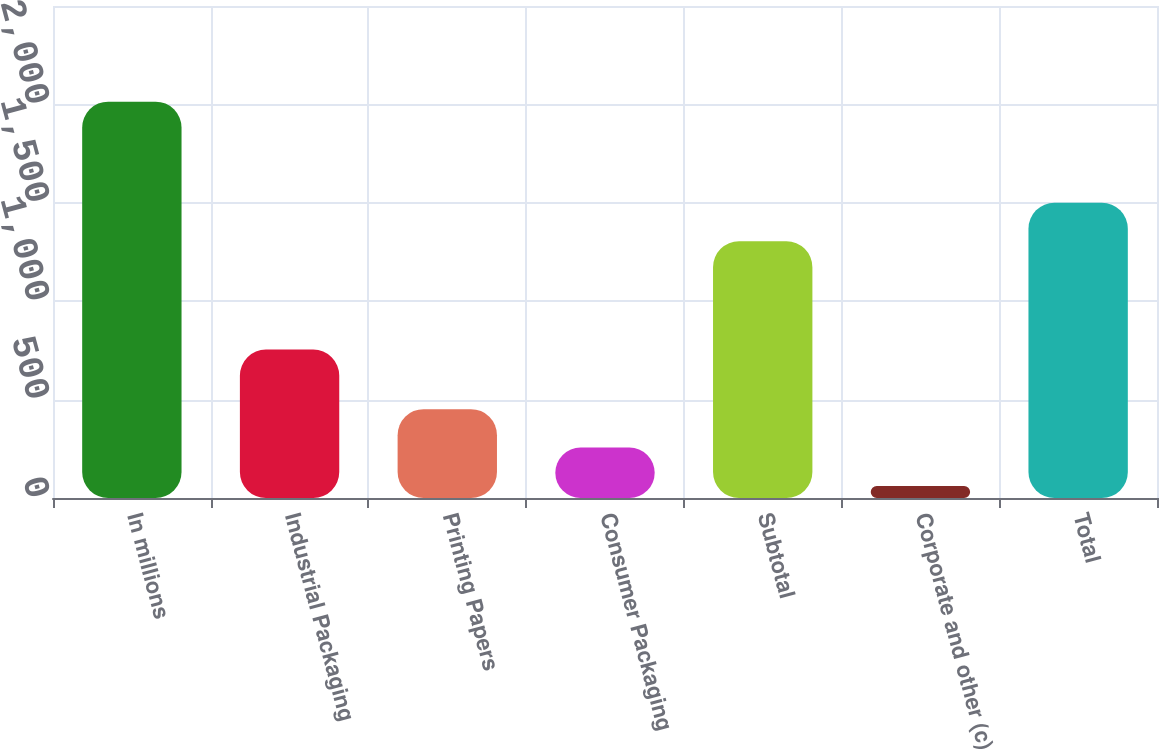Convert chart to OTSL. <chart><loc_0><loc_0><loc_500><loc_500><bar_chart><fcel>In millions<fcel>Industrial Packaging<fcel>Printing Papers<fcel>Consumer Packaging<fcel>Subtotal<fcel>Corporate and other (c)<fcel>Total<nl><fcel>2014<fcel>754<fcel>451.6<fcel>256.3<fcel>1305<fcel>61<fcel>1500.3<nl></chart> 